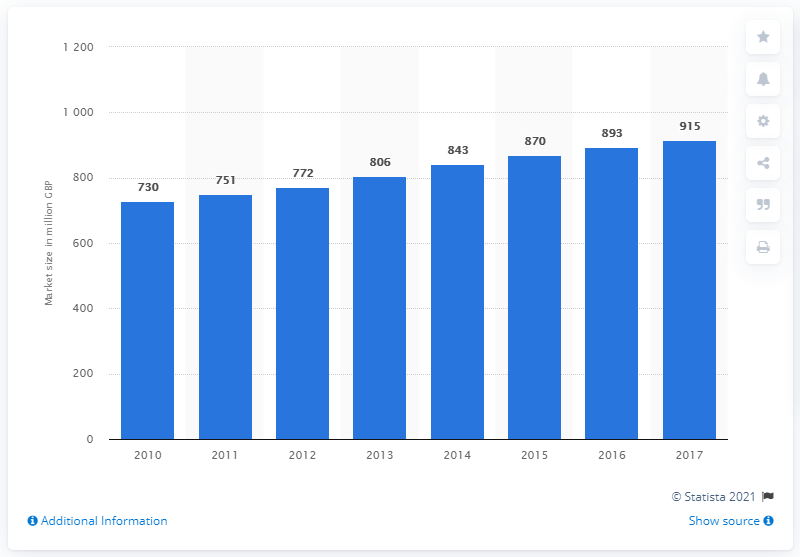Indicate a few pertinent items in this graphic. The estimated size of the hardware segment in the UK in 2017 was approximately 915. In 2010, the UK's hardware segment was estimated to have grown by a substantial 915 million pounds. 